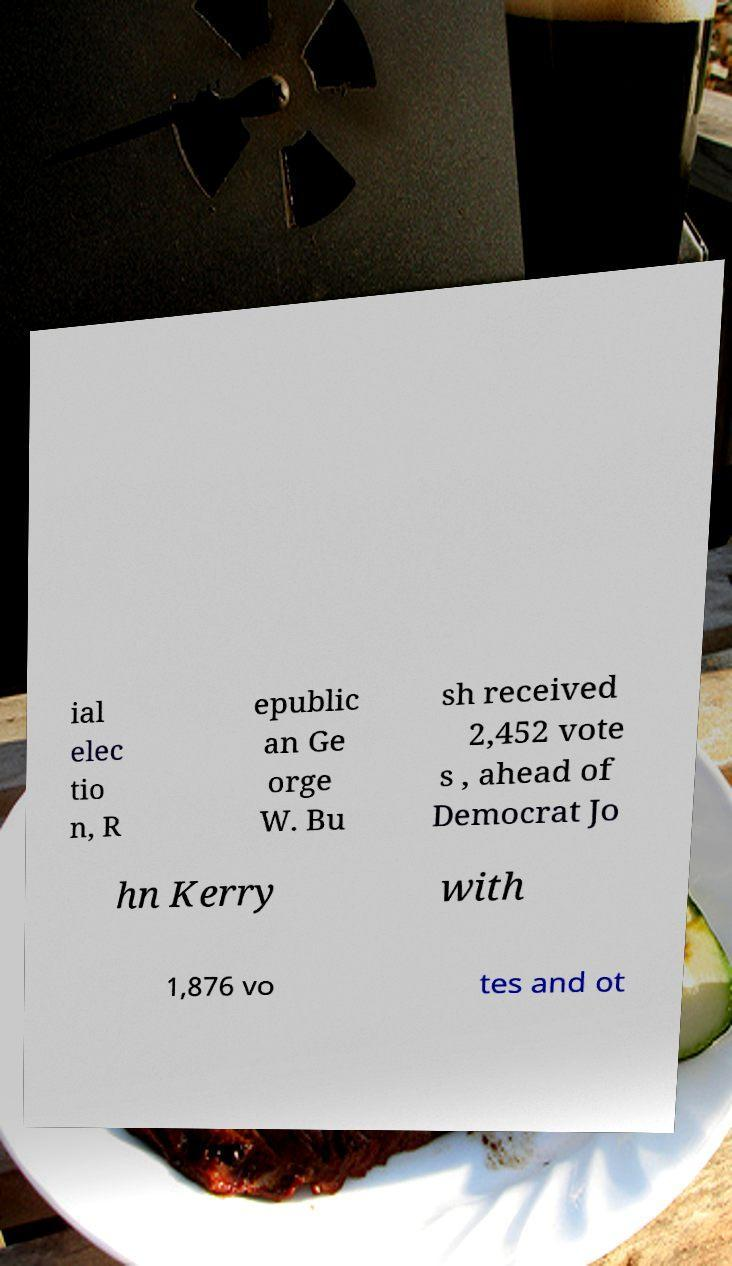Please identify and transcribe the text found in this image. ial elec tio n, R epublic an Ge orge W. Bu sh received 2,452 vote s , ahead of Democrat Jo hn Kerry with 1,876 vo tes and ot 